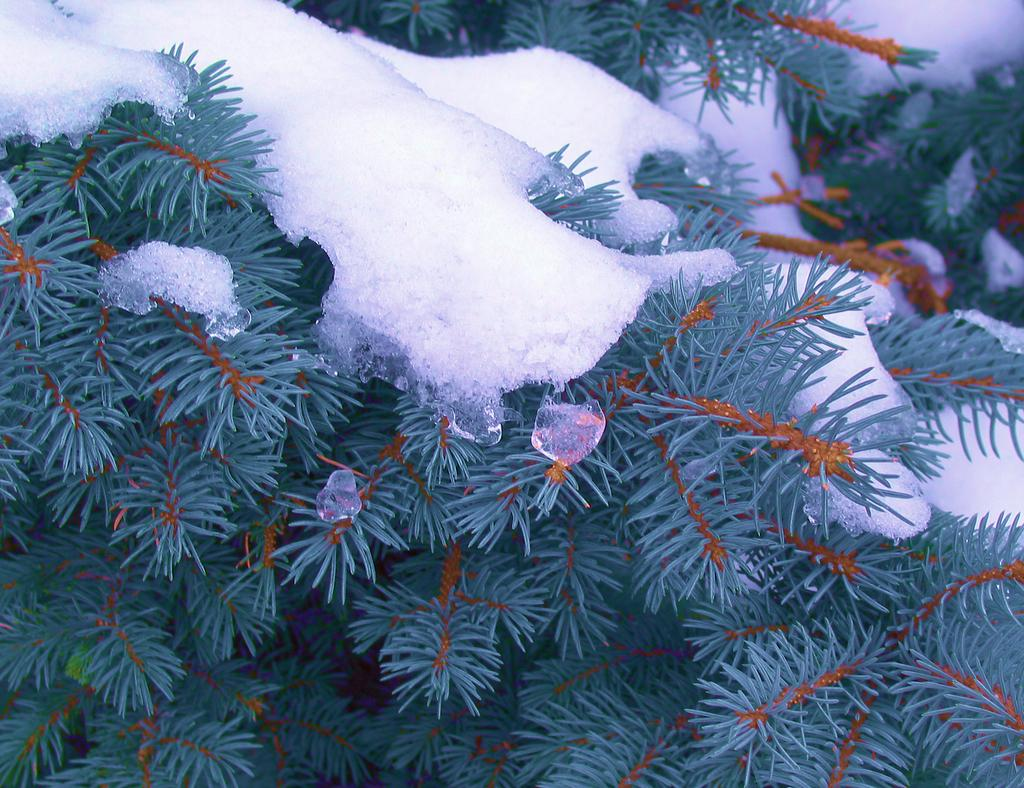What type of living organisms can be seen in the image? Plants can be seen in the image. What color are the leaves of the plants? The leaves of the plants have green color. What additional detail can be observed on the leaves of the plants? There is white snow on the leaves of the plants. How many cattle can be seen grazing on the cherries in the image? There are no cattle or cherries present in the image; it features plants with green leaves and white snow. 